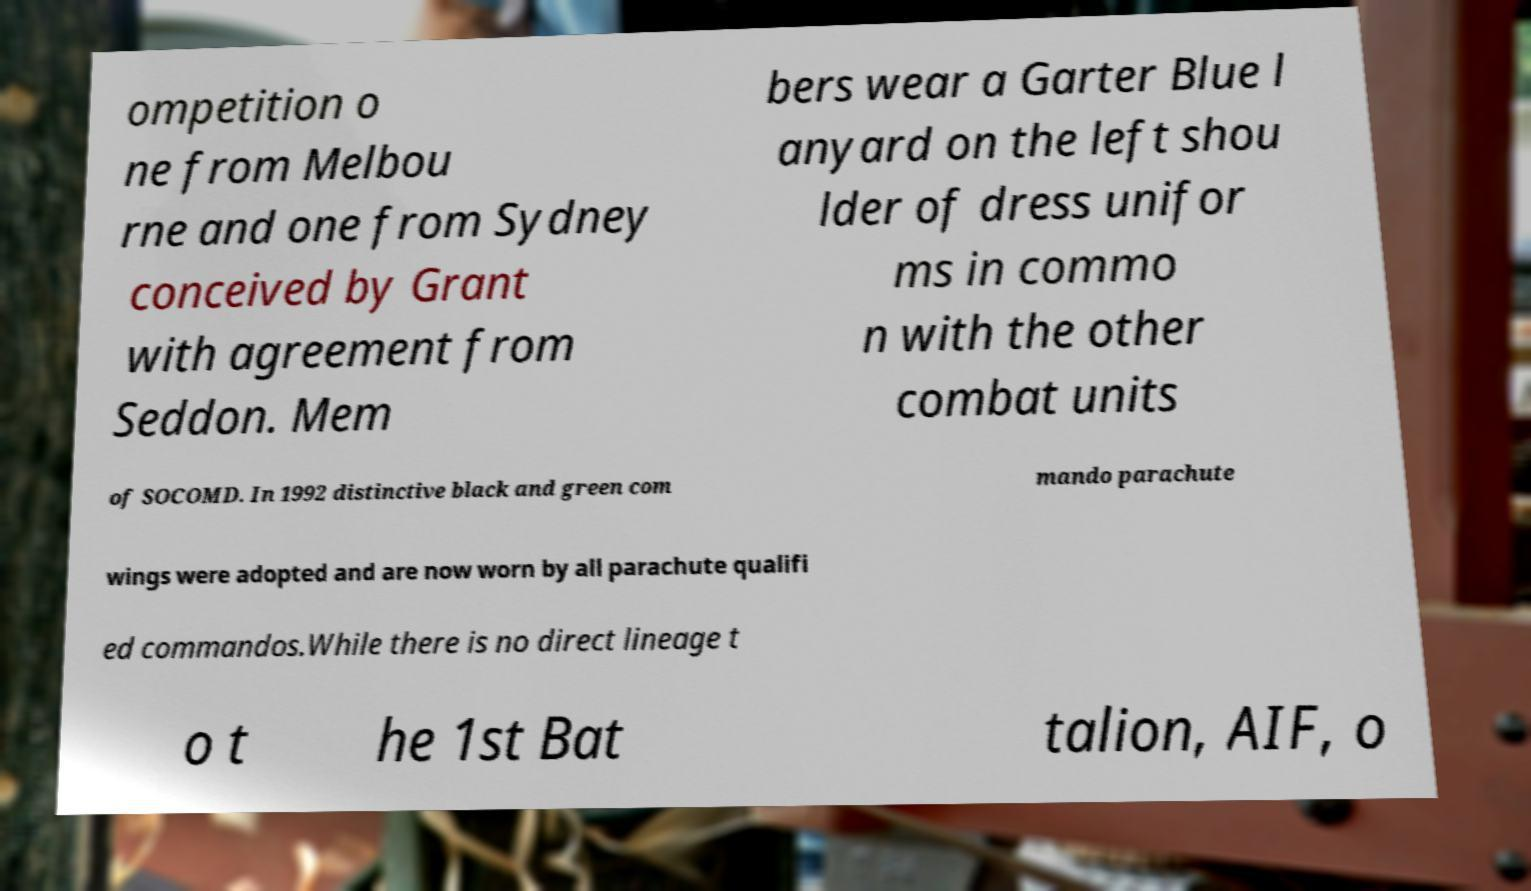Please read and relay the text visible in this image. What does it say? ompetition o ne from Melbou rne and one from Sydney conceived by Grant with agreement from Seddon. Mem bers wear a Garter Blue l anyard on the left shou lder of dress unifor ms in commo n with the other combat units of SOCOMD. In 1992 distinctive black and green com mando parachute wings were adopted and are now worn by all parachute qualifi ed commandos.While there is no direct lineage t o t he 1st Bat talion, AIF, o 